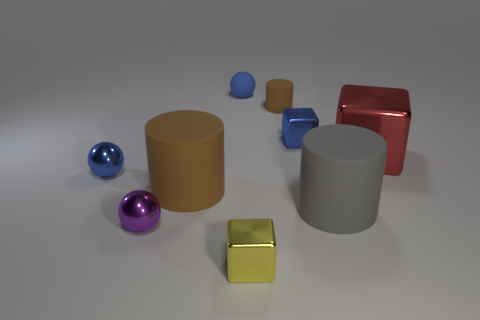Subtract all tiny blue balls. How many balls are left? 1 Subtract all cyan cylinders. How many blue balls are left? 2 Add 1 brown cylinders. How many objects exist? 10 Subtract all yellow blocks. How many blocks are left? 2 Subtract 1 cylinders. How many cylinders are left? 2 Subtract all cylinders. How many objects are left? 6 Add 1 tiny metal balls. How many tiny metal balls exist? 3 Subtract 1 red blocks. How many objects are left? 8 Subtract all brown spheres. Subtract all brown blocks. How many spheres are left? 3 Subtract all large purple metallic balls. Subtract all brown rubber things. How many objects are left? 7 